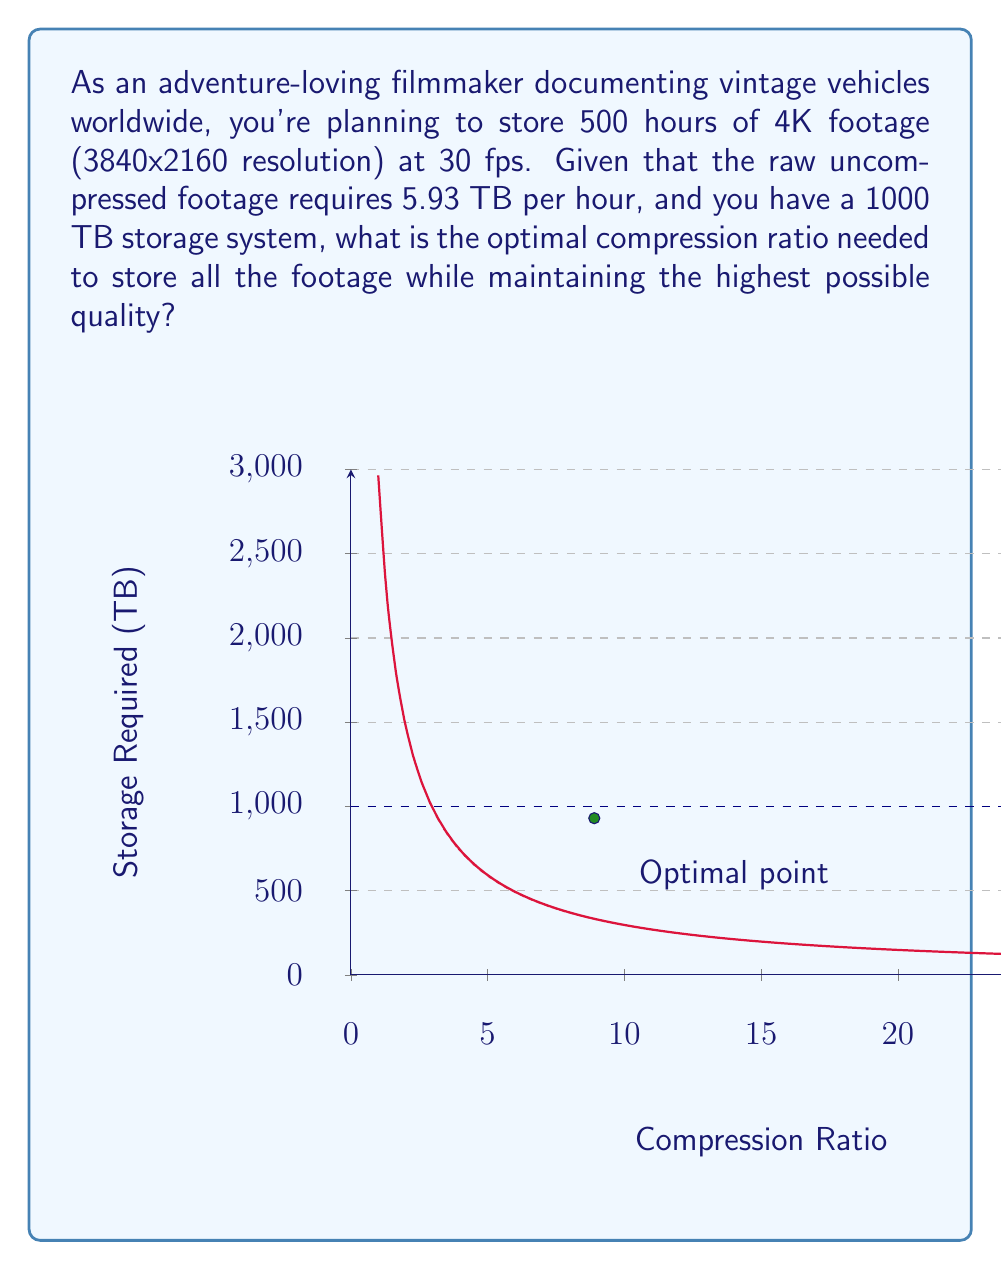Give your solution to this math problem. Let's approach this step-by-step:

1) First, calculate the total storage required for uncompressed footage:
   $$ \text{Total storage} = 500 \text{ hours} \times 5.93 \text{ TB/hour} = 2965 \text{ TB} $$

2) The compression ratio (CR) is defined as:
   $$ \text{CR} = \frac{\text{Uncompressed size}}{\text{Compressed size}} $$

3) We want to find the CR that will reduce the storage to 1000 TB:
   $$ \frac{2965 \text{ TB}}{\text{Compressed size}} = \text{CR} $$
   $$ \frac{2965 \text{ TB}}{\text{CR}} = 1000 \text{ TB} $$

4) Solve for CR:
   $$ \text{CR} = \frac{2965 \text{ TB}}{1000 \text{ TB}} = 2.965 $$

5) However, we need to round up to the next whole number for practical implementation:
   $$ \text{CR} = \lceil 2.965 \rceil = 3 $$

6) This means we need to compress the footage to 1/3 of its original size.

7) To verify:
   $$ \frac{2965 \text{ TB}}{3} \approx 988.33 \text{ TB} < 1000 \text{ TB} $$

Thus, a compression ratio of 3:1 will allow all the footage to fit within the 1000 TB storage while maintaining the highest possible quality.
Answer: 3:1 